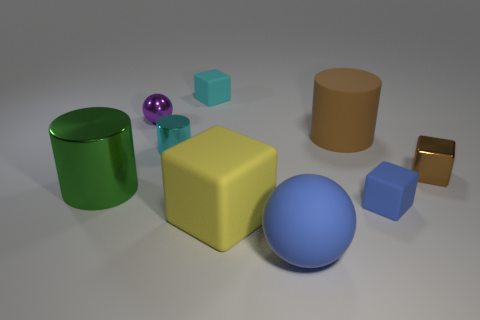There is a cylinder on the left side of the tiny cyan metallic cylinder; what is its color? The cylinder to the left of the small cyan metallic cylinder has a rich green hue that is both striking and vibrant. 